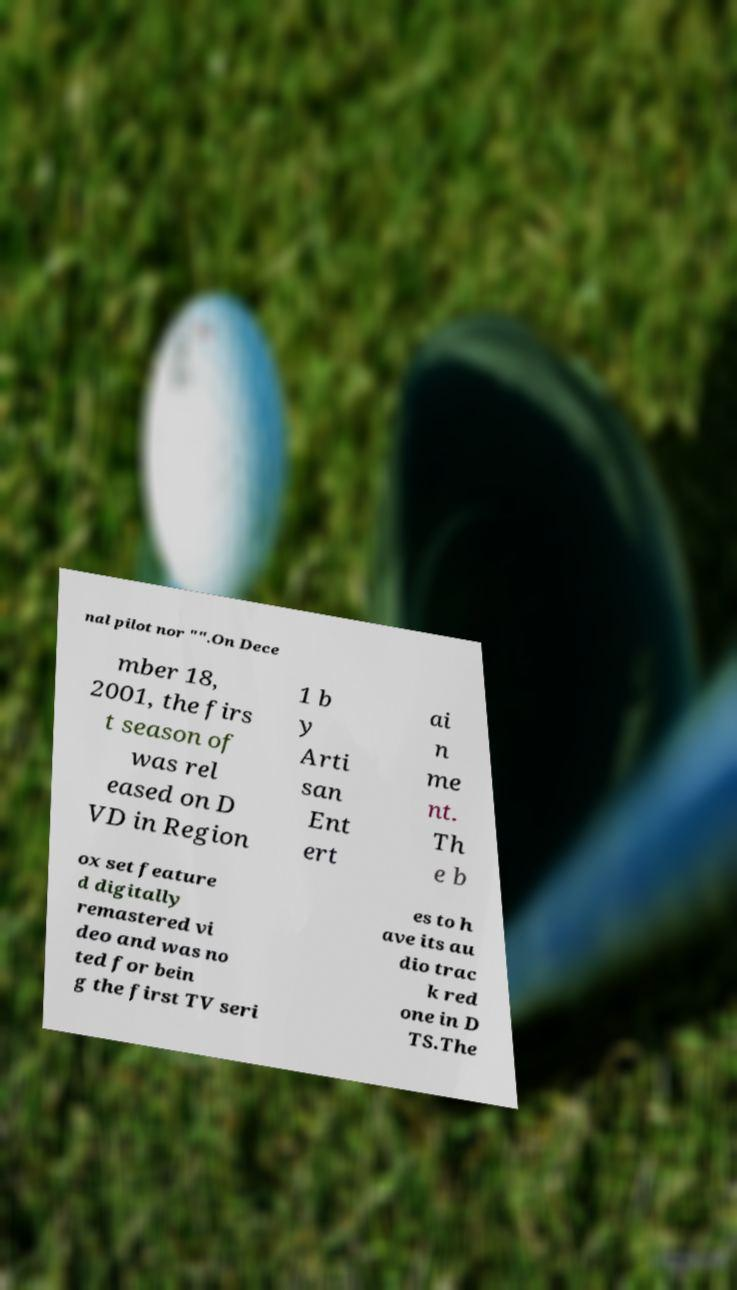I need the written content from this picture converted into text. Can you do that? nal pilot nor "".On Dece mber 18, 2001, the firs t season of was rel eased on D VD in Region 1 b y Arti san Ent ert ai n me nt. Th e b ox set feature d digitally remastered vi deo and was no ted for bein g the first TV seri es to h ave its au dio trac k red one in D TS.The 